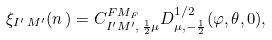Convert formula to latex. <formula><loc_0><loc_0><loc_500><loc_500>\xi _ { I ^ { \prime } \, M ^ { \prime } } ( n \, ) = C ^ { F M _ { F } } _ { I ^ { \prime } M ^ { \prime } , \, \frac { 1 } { 2 } \mu } D ^ { 1 / 2 } _ { \mu , - \frac { 1 } { 2 } } ( \varphi , \theta , 0 ) ,</formula> 